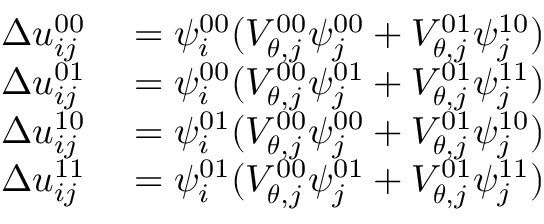Convert formula to latex. <formula><loc_0><loc_0><loc_500><loc_500>\begin{array} { r l } { \Delta u _ { i j } ^ { 0 0 } } & = \psi _ { i } ^ { 0 0 } ( V _ { \theta , j } ^ { 0 0 } \psi _ { j } ^ { 0 0 } + V _ { \theta , j } ^ { 0 1 } \psi _ { j } ^ { 1 0 } ) } \\ { \Delta u _ { i j } ^ { 0 1 } } & = \psi _ { i } ^ { 0 0 } ( V _ { \theta , j } ^ { 0 0 } \psi _ { j } ^ { 0 1 } + V _ { \theta , j } ^ { 0 1 } \psi _ { j } ^ { 1 1 } ) } \\ { \Delta u _ { i j } ^ { 1 0 } } & = \psi _ { i } ^ { 0 1 } ( V _ { \theta , j } ^ { 0 0 } \psi _ { j } ^ { 0 0 } + V _ { \theta , j } ^ { 0 1 } \psi _ { j } ^ { 1 0 } ) } \\ { \Delta u _ { i j } ^ { 1 1 } } & = \psi _ { i } ^ { 0 1 } ( V _ { \theta , j } ^ { 0 0 } \psi _ { j } ^ { 0 1 } + V _ { \theta , j } ^ { 0 1 } \psi _ { j } ^ { 1 1 } ) } \end{array}</formula> 